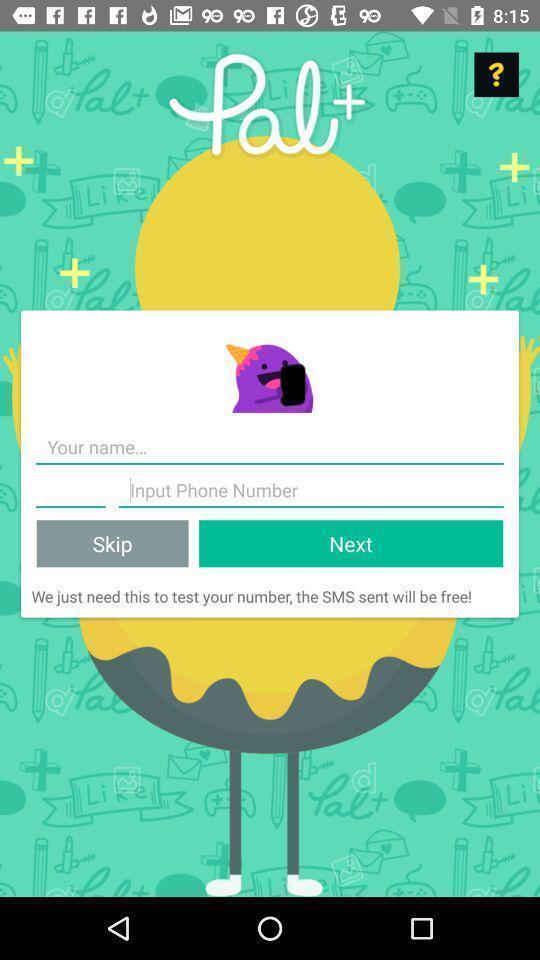Describe this image in words. Sign up page. 